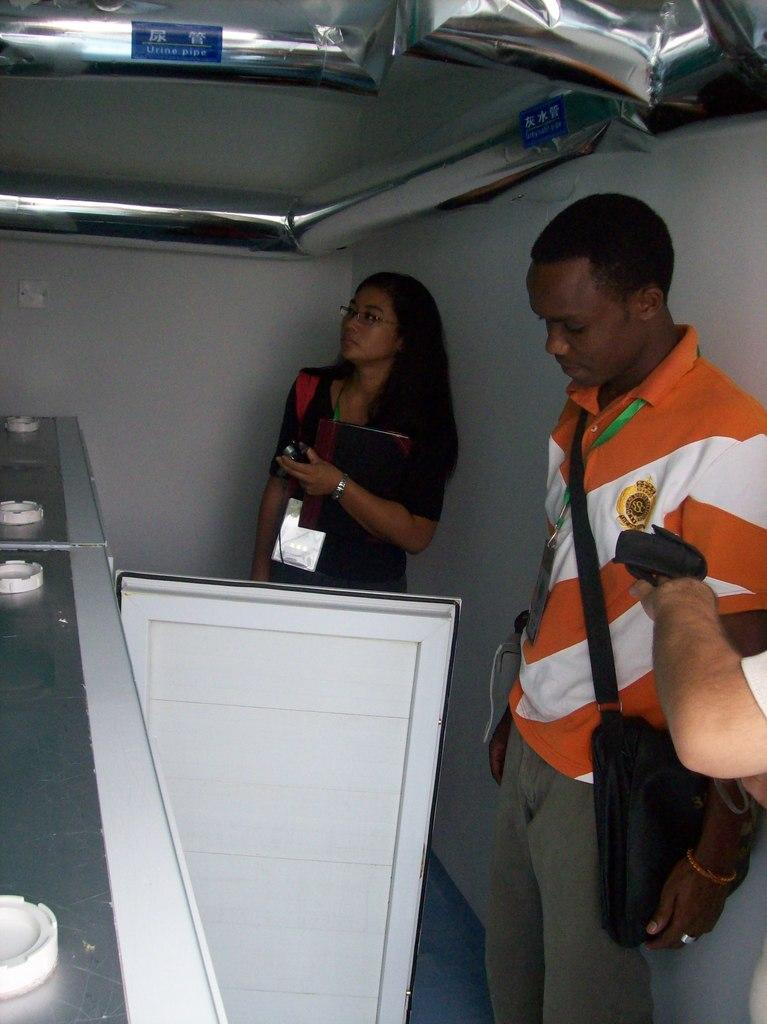How many people are present in the image? There are two persons standing in the image. What is the woman holding in the image? The woman is holding a book. What is the man wearing in the image? The man is wearing a bag. Can you describe any architectural features in the image? Yes, there is a door visible in the image. What type of jewel can be seen on the door in the image? There is no jewel present on the door in the image. How many eggs are visible on the floor in the image? There are no eggs visible on the floor in the image. 